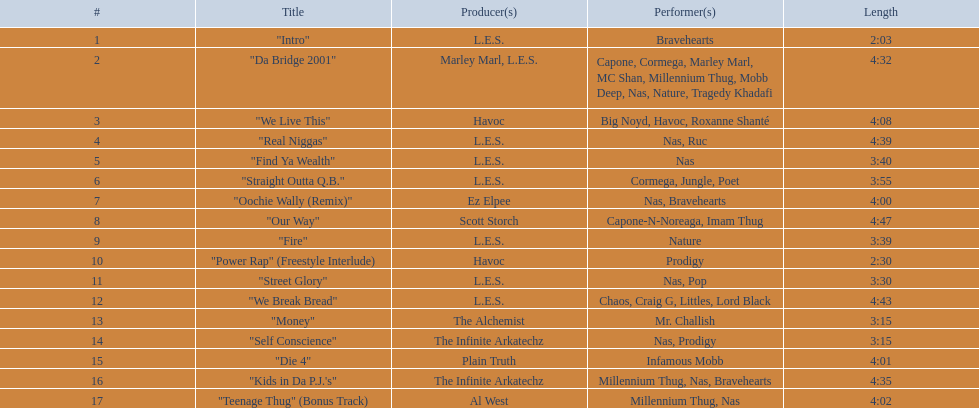How long is each song? 2:03, 4:32, 4:08, 4:39, 3:40, 3:55, 4:00, 4:47, 3:39, 2:30, 3:30, 4:43, 3:15, 3:15, 4:01, 4:35, 4:02. What length is the longest? 4:47. 